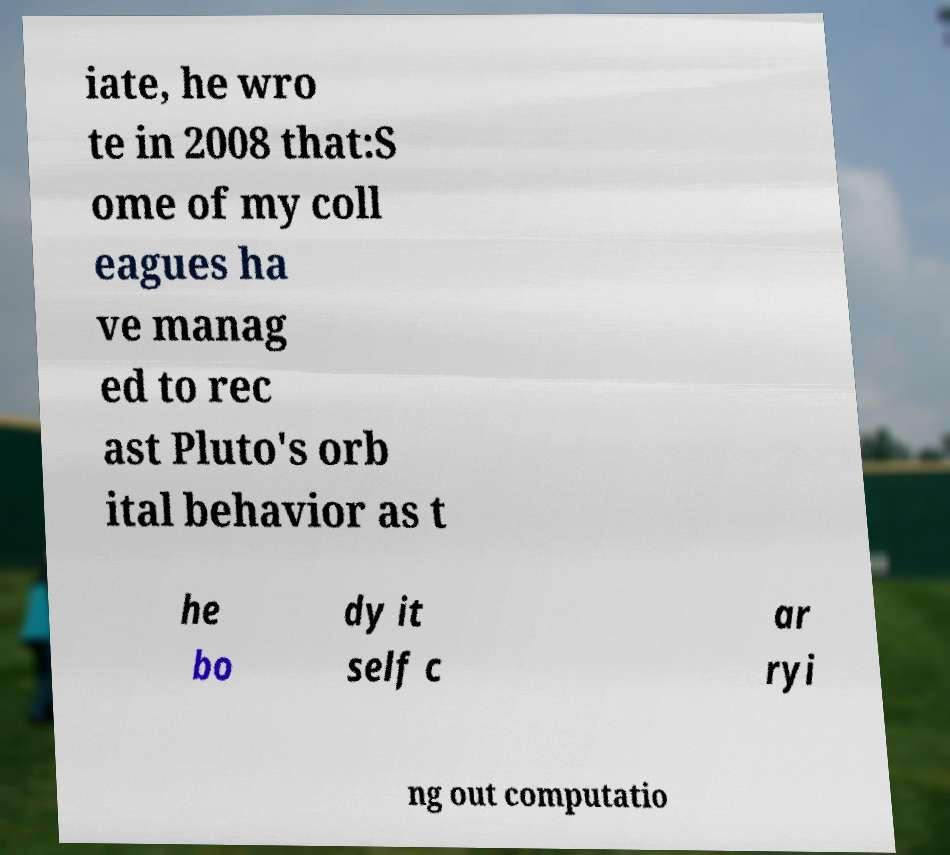What messages or text are displayed in this image? I need them in a readable, typed format. iate, he wro te in 2008 that:S ome of my coll eagues ha ve manag ed to rec ast Pluto's orb ital behavior as t he bo dy it self c ar ryi ng out computatio 